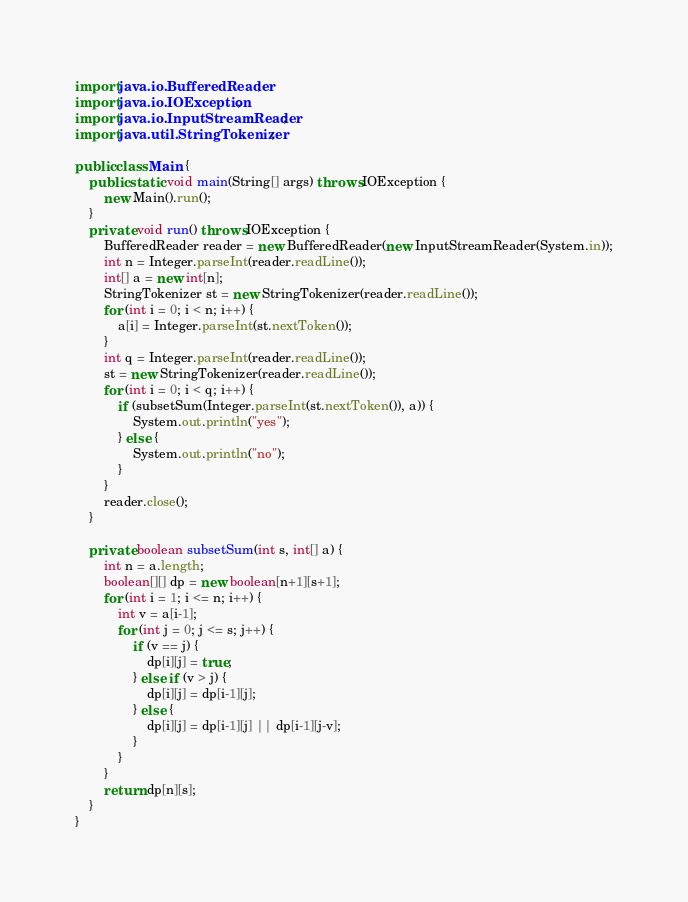<code> <loc_0><loc_0><loc_500><loc_500><_Java_>import java.io.BufferedReader;
import java.io.IOException;
import java.io.InputStreamReader;
import java.util.StringTokenizer;

public class Main {
	public static void main(String[] args) throws IOException {
		new Main().run();
	}
	private void run() throws IOException {
		BufferedReader reader = new BufferedReader(new InputStreamReader(System.in));
		int n = Integer.parseInt(reader.readLine());
		int[] a = new int[n];
		StringTokenizer st = new StringTokenizer(reader.readLine());
		for (int i = 0; i < n; i++) {
			a[i] = Integer.parseInt(st.nextToken());
		}
		int q = Integer.parseInt(reader.readLine());
		st = new StringTokenizer(reader.readLine());
		for (int i = 0; i < q; i++) {
			if (subsetSum(Integer.parseInt(st.nextToken()), a)) {
				System.out.println("yes");
			} else {
				System.out.println("no");
			}
		}
		reader.close();
	}

	private boolean subsetSum(int s, int[] a) {
		int n = a.length;
		boolean[][] dp = new boolean[n+1][s+1];
		for (int i = 1; i <= n; i++) {
			int v = a[i-1];
			for (int j = 0; j <= s; j++) {
				if (v == j) {
					dp[i][j] = true;
				} else if (v > j) {
					dp[i][j] = dp[i-1][j];
				} else {
					dp[i][j] = dp[i-1][j] || dp[i-1][j-v];
				}
			}
		}
		return dp[n][s];
	}
}

</code> 